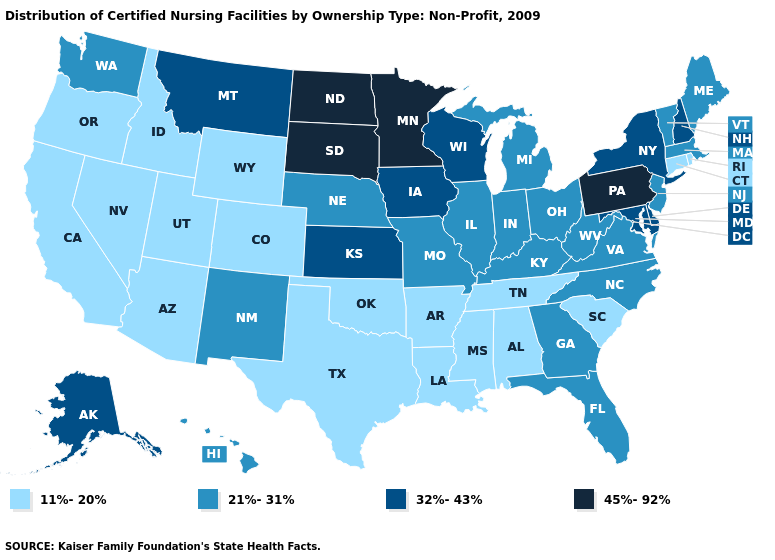Does Maryland have a higher value than South Dakota?
Write a very short answer. No. Does Michigan have the highest value in the USA?
Keep it brief. No. Does the first symbol in the legend represent the smallest category?
Quick response, please. Yes. Does Vermont have a lower value than Illinois?
Quick response, please. No. Name the states that have a value in the range 11%-20%?
Be succinct. Alabama, Arizona, Arkansas, California, Colorado, Connecticut, Idaho, Louisiana, Mississippi, Nevada, Oklahoma, Oregon, Rhode Island, South Carolina, Tennessee, Texas, Utah, Wyoming. Which states have the lowest value in the West?
Keep it brief. Arizona, California, Colorado, Idaho, Nevada, Oregon, Utah, Wyoming. Does New Mexico have the same value as Wyoming?
Be succinct. No. What is the value of Missouri?
Keep it brief. 21%-31%. What is the value of California?
Keep it brief. 11%-20%. Does the map have missing data?
Keep it brief. No. Does Colorado have the lowest value in the West?
Answer briefly. Yes. Does Oklahoma have the highest value in the USA?
Answer briefly. No. What is the value of Tennessee?
Concise answer only. 11%-20%. What is the value of Wyoming?
Concise answer only. 11%-20%. Does Pennsylvania have the lowest value in the Northeast?
Give a very brief answer. No. 